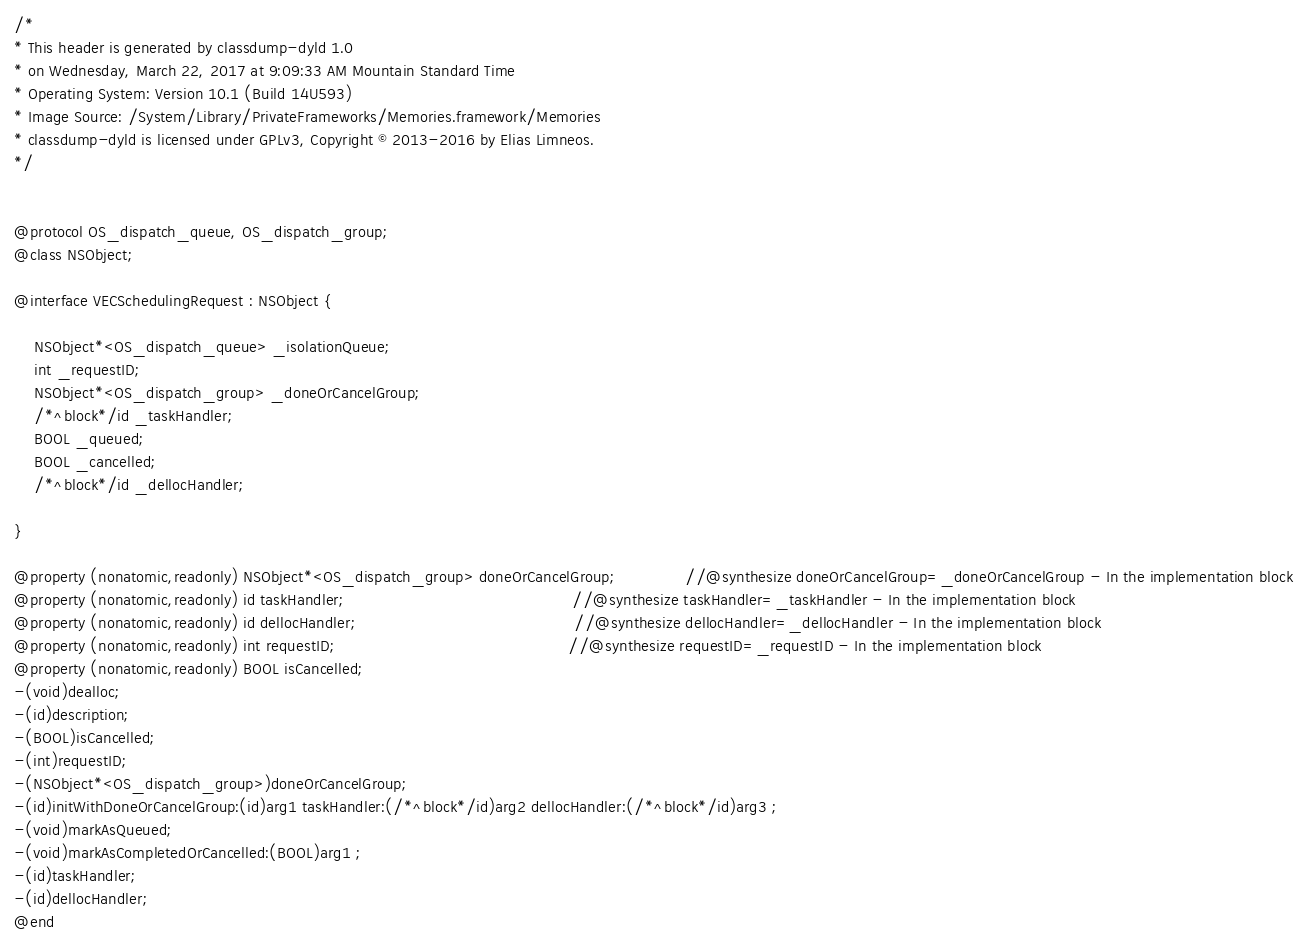Convert code to text. <code><loc_0><loc_0><loc_500><loc_500><_C_>/*
* This header is generated by classdump-dyld 1.0
* on Wednesday, March 22, 2017 at 9:09:33 AM Mountain Standard Time
* Operating System: Version 10.1 (Build 14U593)
* Image Source: /System/Library/PrivateFrameworks/Memories.framework/Memories
* classdump-dyld is licensed under GPLv3, Copyright © 2013-2016 by Elias Limneos.
*/


@protocol OS_dispatch_queue, OS_dispatch_group;
@class NSObject;

@interface VECSchedulingRequest : NSObject {

	NSObject*<OS_dispatch_queue> _isolationQueue;
	int _requestID;
	NSObject*<OS_dispatch_group> _doneOrCancelGroup;
	/*^block*/id _taskHandler;
	BOOL _queued;
	BOOL _cancelled;
	/*^block*/id _dellocHandler;

}

@property (nonatomic,readonly) NSObject*<OS_dispatch_group> doneOrCancelGroup;              //@synthesize doneOrCancelGroup=_doneOrCancelGroup - In the implementation block
@property (nonatomic,readonly) id taskHandler;                                              //@synthesize taskHandler=_taskHandler - In the implementation block
@property (nonatomic,readonly) id dellocHandler;                                            //@synthesize dellocHandler=_dellocHandler - In the implementation block
@property (nonatomic,readonly) int requestID;                                               //@synthesize requestID=_requestID - In the implementation block
@property (nonatomic,readonly) BOOL isCancelled; 
-(void)dealloc;
-(id)description;
-(BOOL)isCancelled;
-(int)requestID;
-(NSObject*<OS_dispatch_group>)doneOrCancelGroup;
-(id)initWithDoneOrCancelGroup:(id)arg1 taskHandler:(/*^block*/id)arg2 dellocHandler:(/*^block*/id)arg3 ;
-(void)markAsQueued;
-(void)markAsCompletedOrCancelled:(BOOL)arg1 ;
-(id)taskHandler;
-(id)dellocHandler;
@end

</code> 